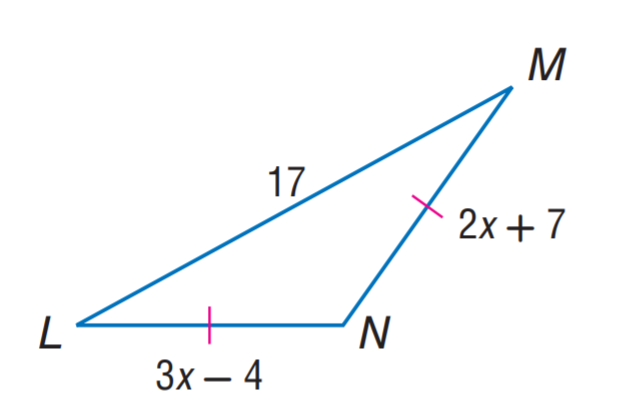Answer the mathemtical geometry problem and directly provide the correct option letter.
Question: Find L N.
Choices: A: 11 B: 15 C: 17 D: 29 D 